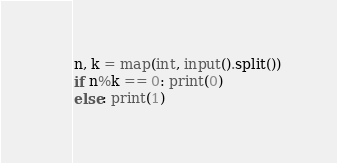<code> <loc_0><loc_0><loc_500><loc_500><_Python_>n, k = map(int, input().split())
if n%k == 0: print(0)
else: print(1)</code> 